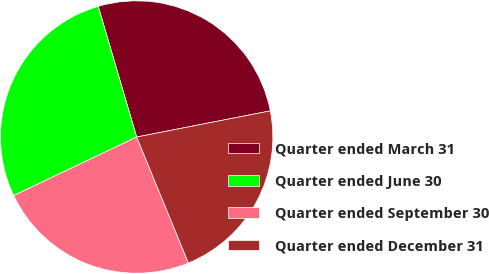<chart> <loc_0><loc_0><loc_500><loc_500><pie_chart><fcel>Quarter ended March 31<fcel>Quarter ended June 30<fcel>Quarter ended September 30<fcel>Quarter ended December 31<nl><fcel>26.48%<fcel>27.52%<fcel>24.13%<fcel>21.87%<nl></chart> 